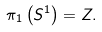Convert formula to latex. <formula><loc_0><loc_0><loc_500><loc_500>\pi _ { 1 } \left ( S ^ { 1 } \right ) = Z .</formula> 